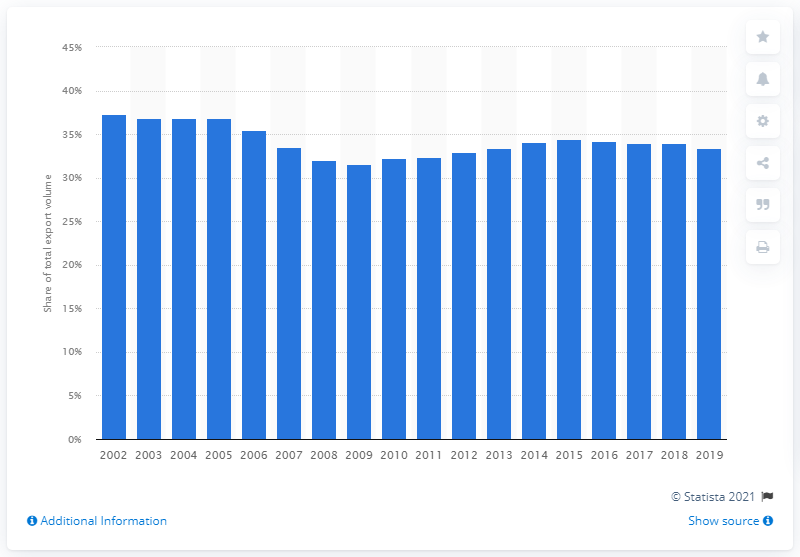Indicate a few pertinent items in this graphic. In 2002, the percentage of total U.S. merchandise exports was directed towards NAFTA members Canada and Mexico. 